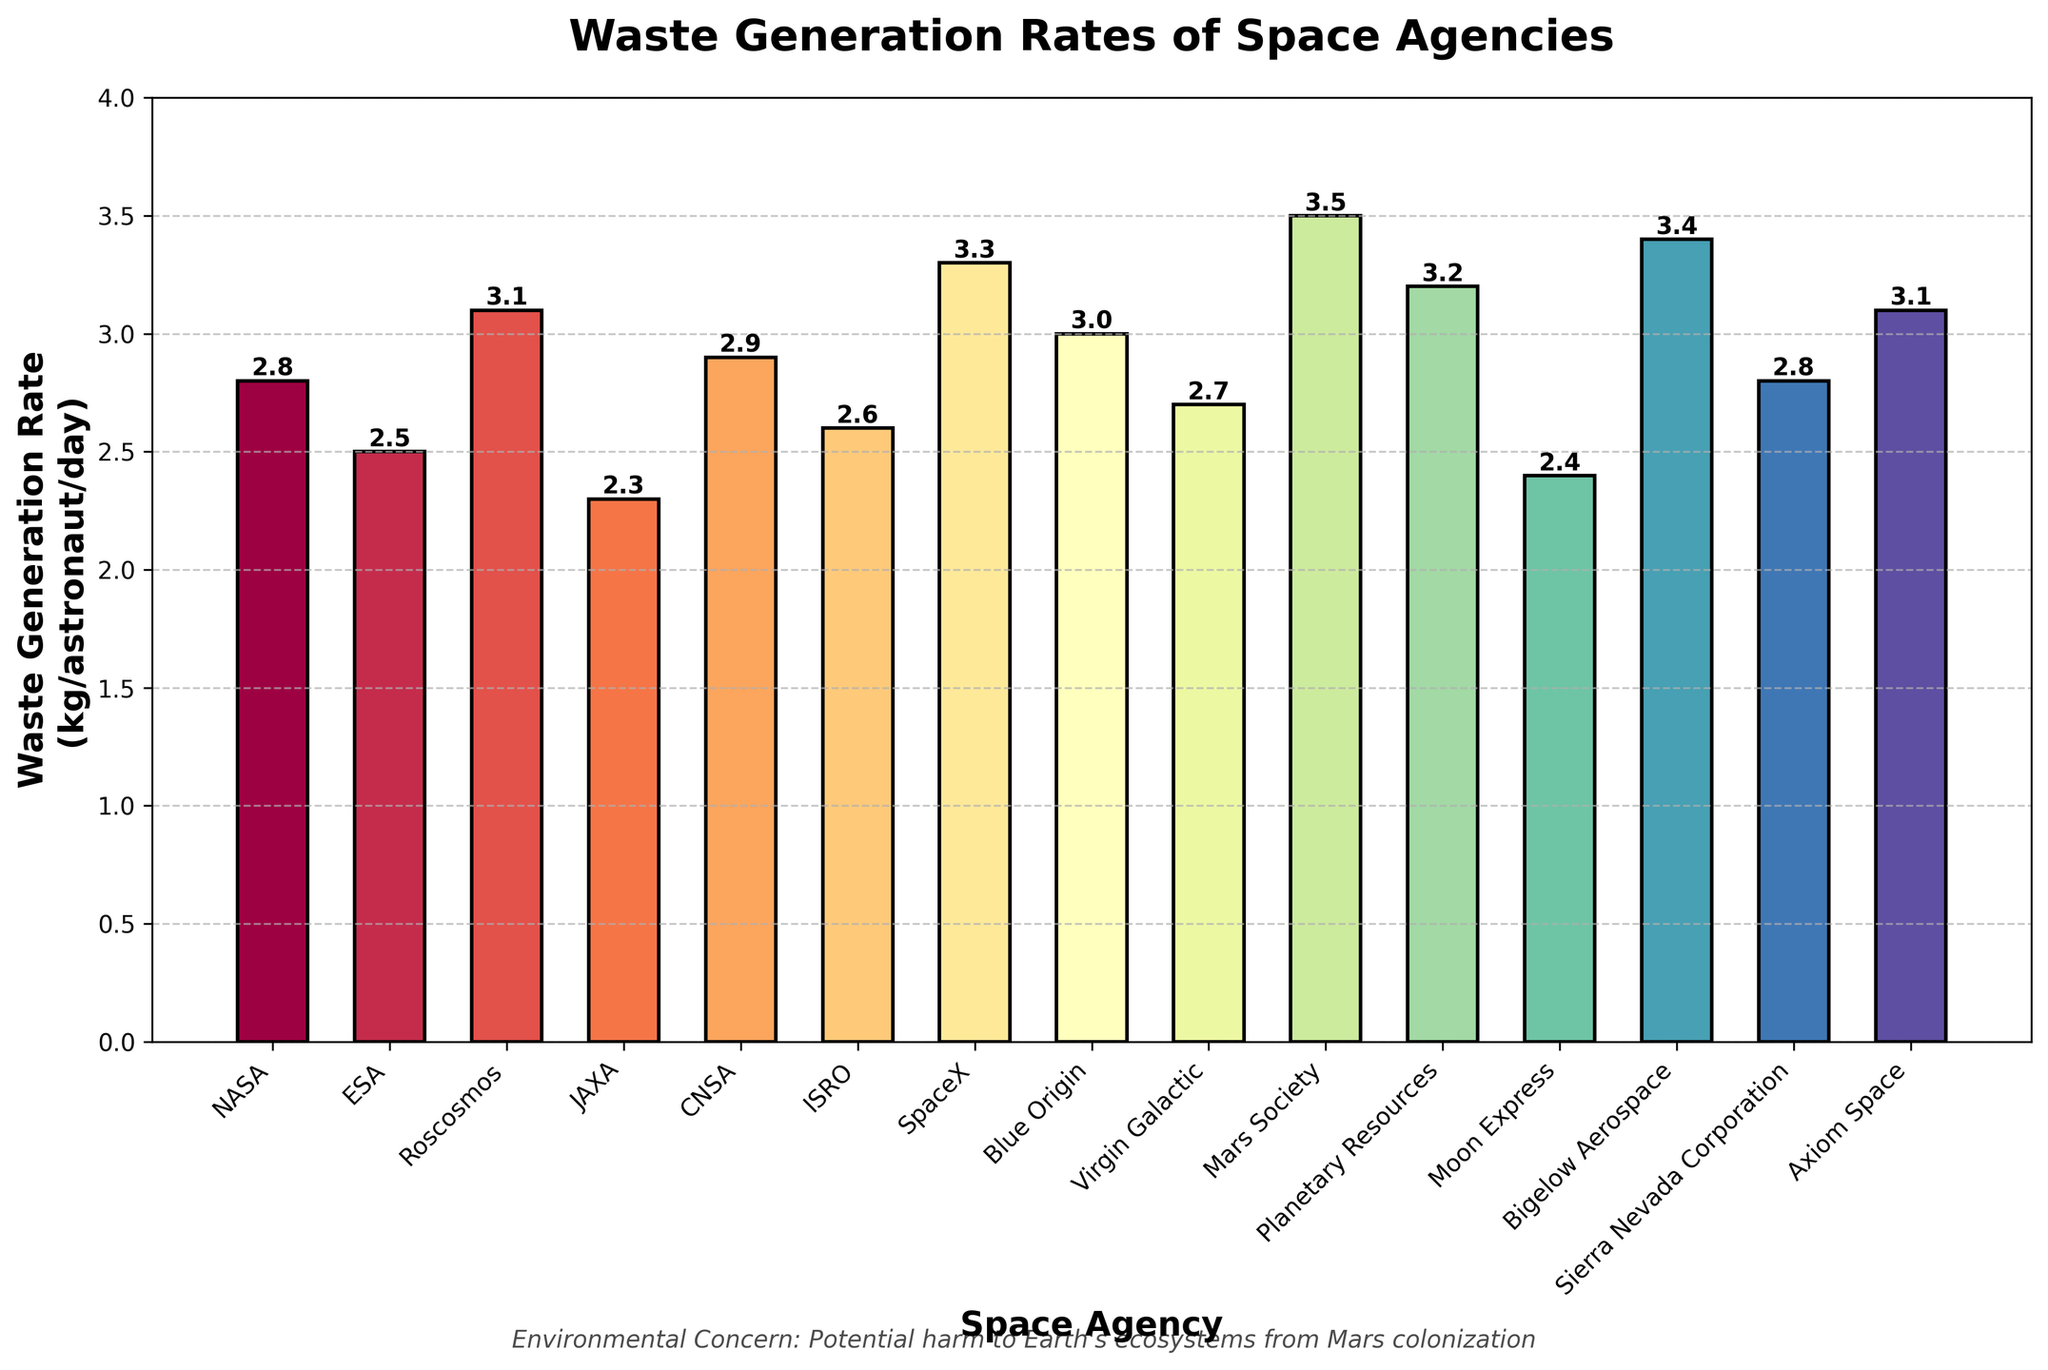What is the waste generation rate of NASA? By looking at the bar corresponding to NASA, we can read the height of the bar and the value label on top of it, which indicates the waste generation rate.
Answer: 2.8 kg/astronaut/day Which space agency has the highest waste generation rate, and what is that rate? By comparing the heights of all the bars, we can see the tallest bar belongs to Mars Society with a value label on top of 3.5 kg/astronaut/day.
Answer: Mars Society, 3.5 kg/astronaut/day How much more waste does Blue Origin generate compared to Virgin Galactic? Blue Origin has a waste generation rate label of 3.0 kg/astronaut/day, and Virgin Galactic has 2.7 kg/astronaut/day. The difference is 3.0 - 2.7.
Answer: 0.3 kg/astronaut/day What is the total waste generation rate of ESA, JAXA, and CNSA combined? ESA has a rate of 2.5, JAXA has 2.3, and CNSA has 2.9. Summing these values: 2.5 + 2.3 + 2.9.
Answer: 7.7 kg/astronaut/day Which agency has a lower waste generation rate, Roscosmos or ISRO, and by how much? Roscosmos has a rate of 3.1, and ISRO has 2.6. Subtracting these values gives the difference: 3.1 - 2.6.
Answer: ISRO, by 0.5 kg/astronaut/day What is the median waste generation rate for all listed agencies? First, list the rates in ascending order: 2.3, 2.4, 2.5, 2.6, 2.7, 2.8, 2.8, 2.9, 3.0, 3.1, 3.1, 3.2, 3.3, 3.4, 3.5. The median is the middle value of this ordered list.
Answer: 2.9 kg/astronaut/day Of the space agencies, which ones generate waste at a rate higher than 3.0 kg/astronaut/day? Identifying the bars whose heights are above the 3.0 mark: Roscosmos, SpaceX, Blue Origin, Mars Society, Planetary Resources, Bigelow Aerospace, Axiom Space.
Answer: Roscosmos, SpaceX, Blue Origin, Mars Society, Planetary Resources, Bigelow Aerospace, Axiom Space What is the average waste generation rate of all the space agencies listed? Add all the waste generation rates together and divide by the number of agencies (15): (2.8 + 2.5 + 3.1 + 2.3 + 2.9 + 2.6 + 3.3 + 3.0 + 2.7 + 3.5 + 3.2 + 2.4 + 3.4 + 2.8 + 3.1) / 15.
Answer: 2.97 kg/astronaut/day 